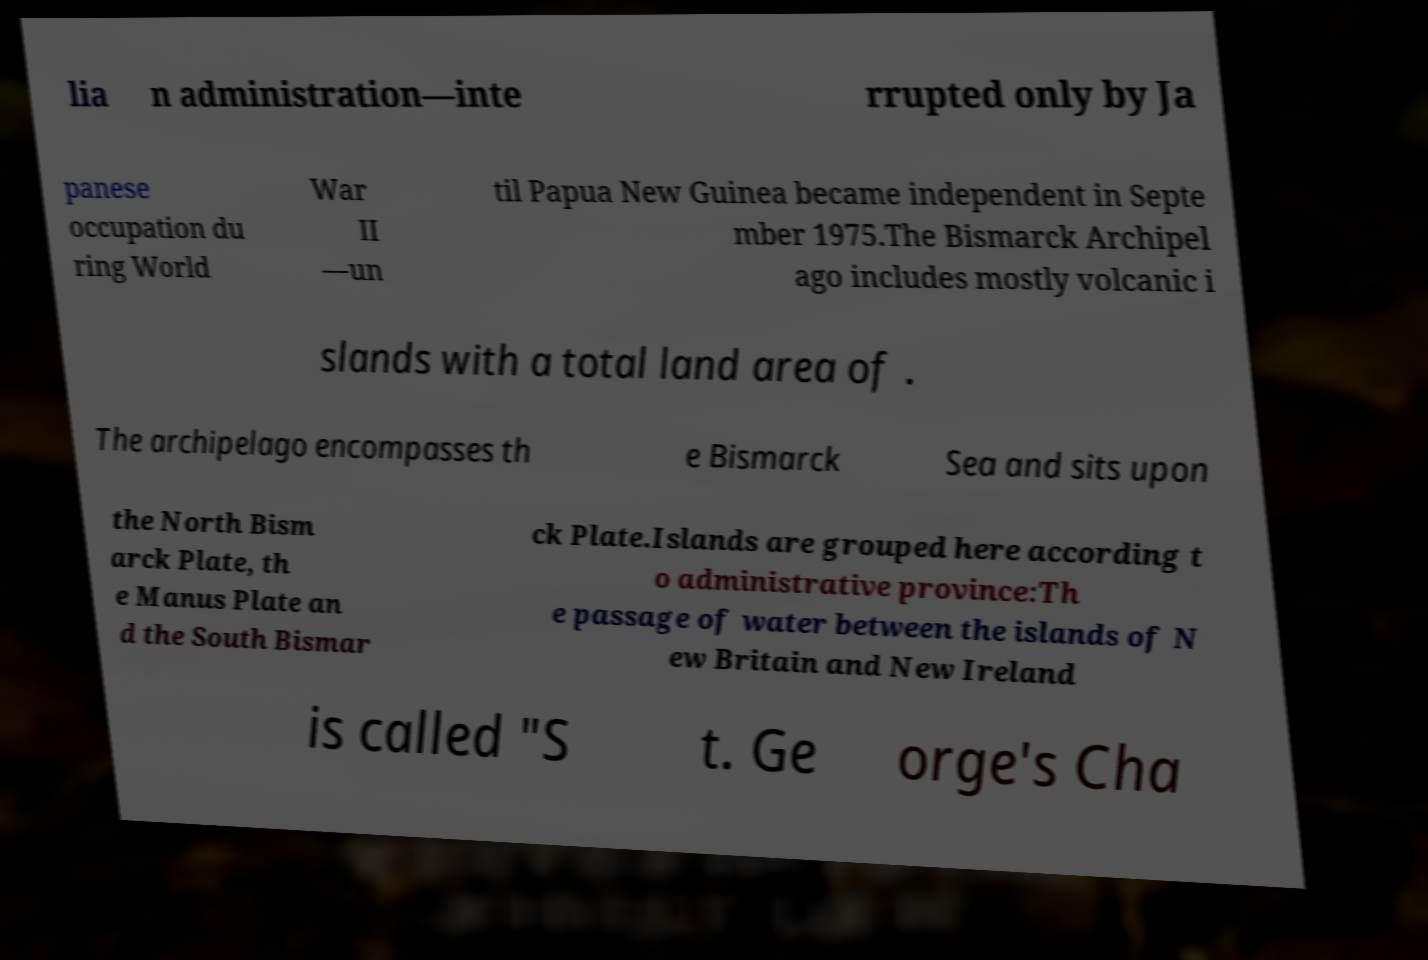For documentation purposes, I need the text within this image transcribed. Could you provide that? lia n administration—inte rrupted only by Ja panese occupation du ring World War II —un til Papua New Guinea became independent in Septe mber 1975.The Bismarck Archipel ago includes mostly volcanic i slands with a total land area of . The archipelago encompasses th e Bismarck Sea and sits upon the North Bism arck Plate, th e Manus Plate an d the South Bismar ck Plate.Islands are grouped here according t o administrative province:Th e passage of water between the islands of N ew Britain and New Ireland is called "S t. Ge orge's Cha 